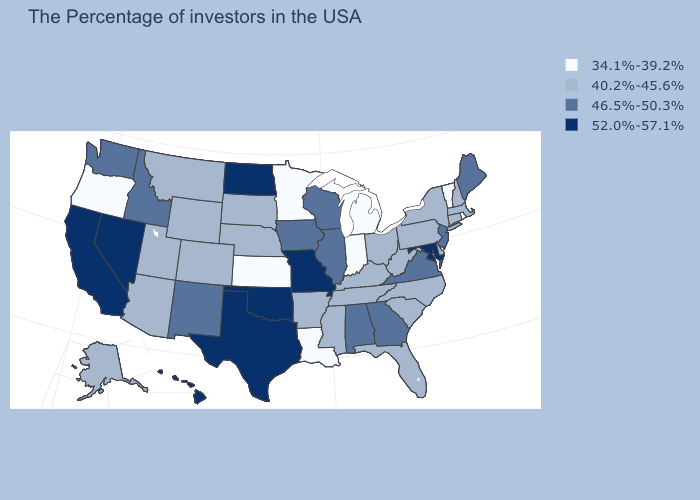What is the value of Idaho?
Be succinct. 46.5%-50.3%. What is the value of Arizona?
Be succinct. 40.2%-45.6%. Which states have the lowest value in the USA?
Short answer required. Rhode Island, Vermont, Michigan, Indiana, Louisiana, Minnesota, Kansas, Oregon. Which states hav the highest value in the West?
Keep it brief. Nevada, California, Hawaii. What is the value of Louisiana?
Concise answer only. 34.1%-39.2%. What is the value of New Jersey?
Concise answer only. 46.5%-50.3%. Among the states that border Virginia , does Maryland have the highest value?
Give a very brief answer. Yes. What is the lowest value in the USA?
Short answer required. 34.1%-39.2%. Does Nebraska have a higher value than Texas?
Keep it brief. No. Name the states that have a value in the range 46.5%-50.3%?
Answer briefly. Maine, New Jersey, Virginia, Georgia, Alabama, Wisconsin, Illinois, Iowa, New Mexico, Idaho, Washington. Name the states that have a value in the range 40.2%-45.6%?
Quick response, please. Massachusetts, New Hampshire, Connecticut, New York, Delaware, Pennsylvania, North Carolina, South Carolina, West Virginia, Ohio, Florida, Kentucky, Tennessee, Mississippi, Arkansas, Nebraska, South Dakota, Wyoming, Colorado, Utah, Montana, Arizona, Alaska. Name the states that have a value in the range 34.1%-39.2%?
Short answer required. Rhode Island, Vermont, Michigan, Indiana, Louisiana, Minnesota, Kansas, Oregon. Name the states that have a value in the range 52.0%-57.1%?
Quick response, please. Maryland, Missouri, Oklahoma, Texas, North Dakota, Nevada, California, Hawaii. Does the first symbol in the legend represent the smallest category?
Concise answer only. Yes. Does Hawaii have the highest value in the USA?
Answer briefly. Yes. 